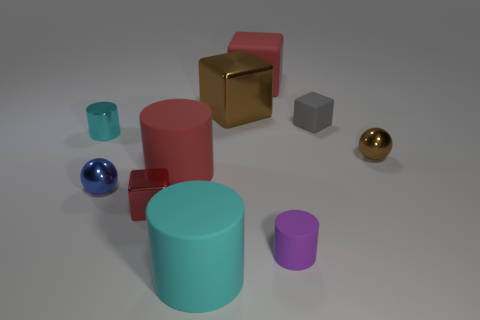The big red object that is in front of the tiny brown metallic thing in front of the cyan object that is on the left side of the blue thing is what shape?
Offer a very short reply. Cylinder. Are there more small cyan metallic things that are in front of the purple matte object than large cyan cylinders?
Provide a short and direct response. No. Is there another big thing of the same shape as the cyan matte thing?
Keep it short and to the point. Yes. Is the material of the small purple cylinder the same as the large red object that is behind the big brown metallic thing?
Your response must be concise. Yes. What color is the large metallic block?
Give a very brief answer. Brown. How many small balls are right of the red block left of the rubber object that is in front of the small purple thing?
Make the answer very short. 1. There is a large brown metal thing; are there any red matte objects behind it?
Make the answer very short. Yes. What number of large things have the same material as the tiny purple object?
Provide a succinct answer. 3. What number of objects are cyan matte balls or cyan objects?
Make the answer very short. 2. Are any purple shiny blocks visible?
Provide a succinct answer. No. 